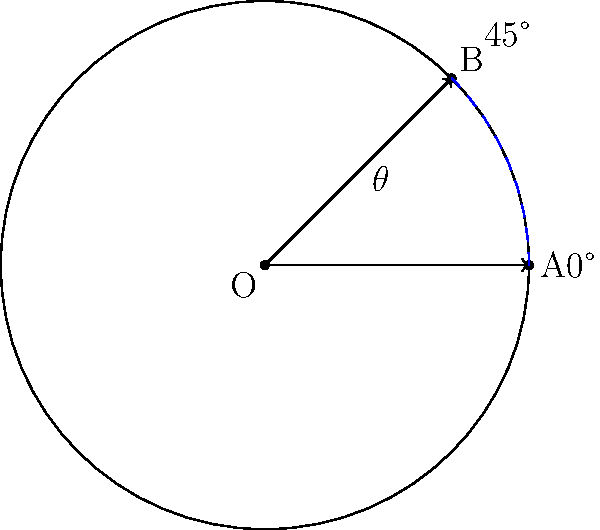You're designing a circular app icon that needs to be rotated to align with a grid layout in your latest project. The icon is currently positioned at 0° (point A) and needs to be rotated to 45° (point B) to fit the grid. How many degrees should you rotate the icon? To solve this problem, we need to understand that the rotation angle is the angle between the initial position (0°) and the final position (45°). Let's break it down step-by-step:

1. Initial position of the icon: 0° (point A)
2. Final position of the icon: 45° (point B)
3. Rotation angle ($\theta$): Final position - Initial position

Calculate:
$$\theta = 45° - 0° = 45°$$

Therefore, you need to rotate the icon by 45° clockwise to align it with the grid layout.

In app development, this rotation can typically be achieved using built-in functions or methods provided by the development framework or graphics library you're using. For example, in many programming languages or frameworks, you might use something like:

```
icon.rotation = 45
```

or

```
rotateIcon(45)
```

Remember that some systems might use radians instead of degrees. In that case, you'd need to convert 45° to radians:

$$45° \times \frac{\pi}{180°} \approx 0.7854 \text{ radians}$$
Answer: 45° 